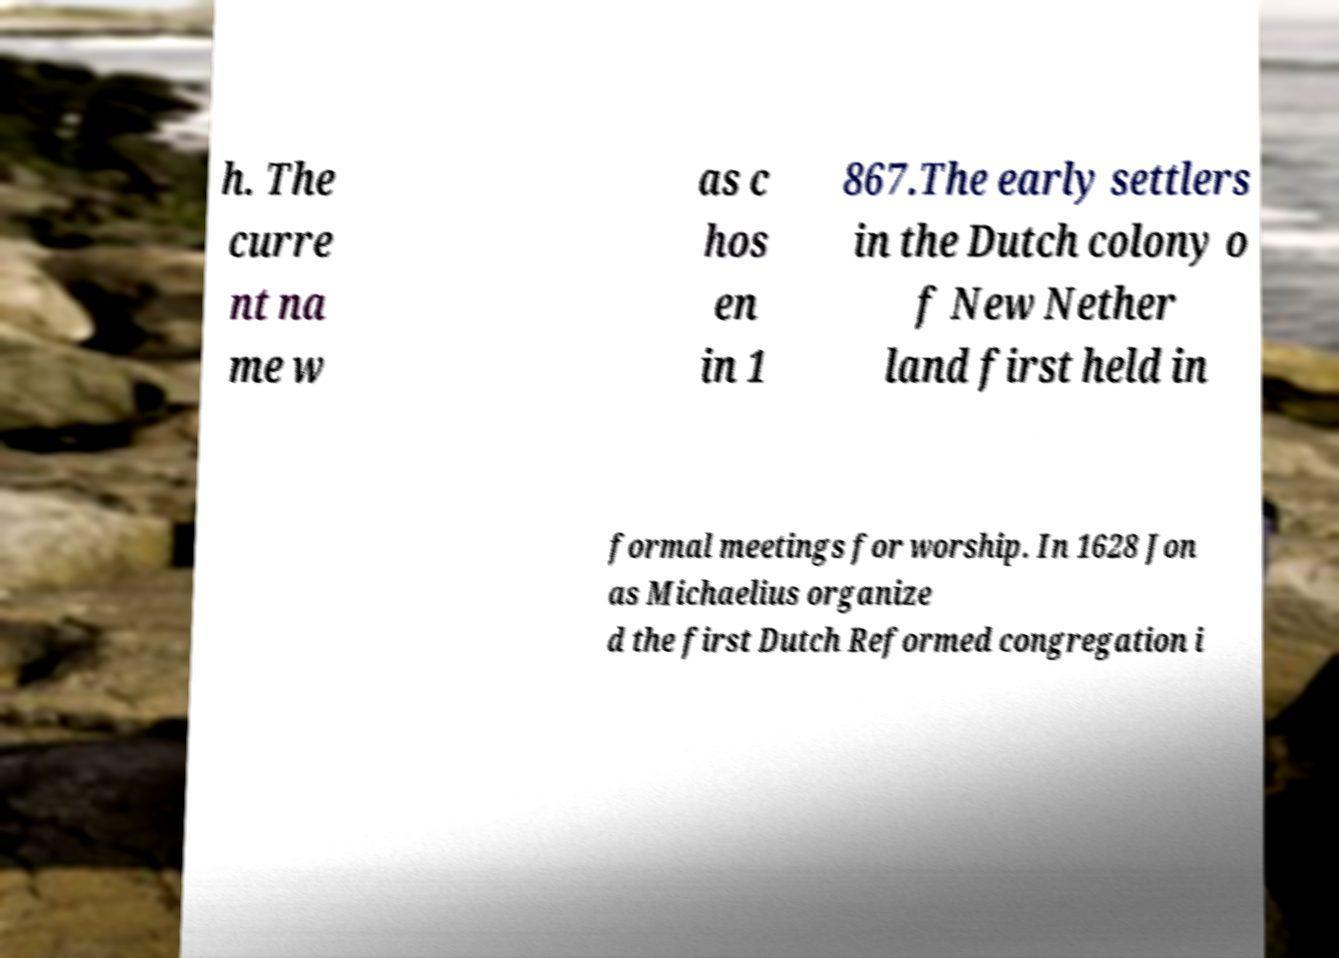Can you read and provide the text displayed in the image?This photo seems to have some interesting text. Can you extract and type it out for me? h. The curre nt na me w as c hos en in 1 867.The early settlers in the Dutch colony o f New Nether land first held in formal meetings for worship. In 1628 Jon as Michaelius organize d the first Dutch Reformed congregation i 